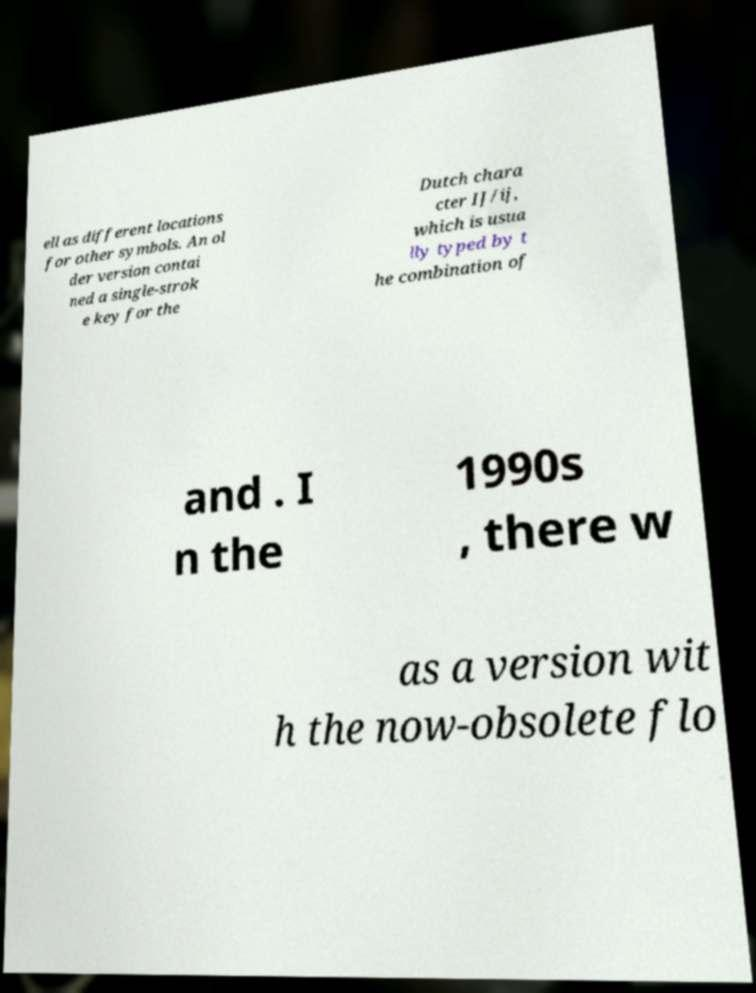What messages or text are displayed in this image? I need them in a readable, typed format. ell as different locations for other symbols. An ol der version contai ned a single-strok e key for the Dutch chara cter IJ/ij, which is usua lly typed by t he combination of and . I n the 1990s , there w as a version wit h the now-obsolete flo 